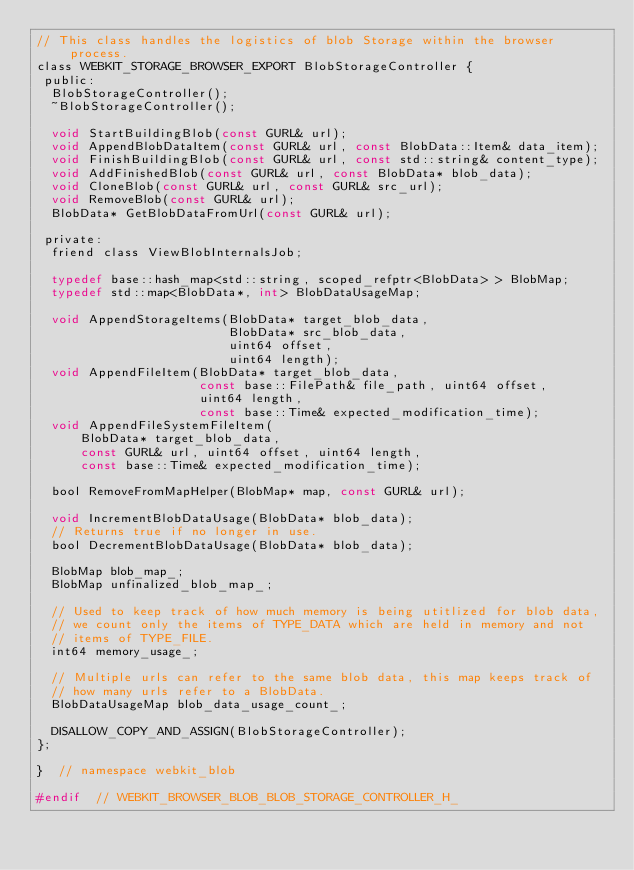Convert code to text. <code><loc_0><loc_0><loc_500><loc_500><_C_>// This class handles the logistics of blob Storage within the browser process.
class WEBKIT_STORAGE_BROWSER_EXPORT BlobStorageController {
 public:
  BlobStorageController();
  ~BlobStorageController();

  void StartBuildingBlob(const GURL& url);
  void AppendBlobDataItem(const GURL& url, const BlobData::Item& data_item);
  void FinishBuildingBlob(const GURL& url, const std::string& content_type);
  void AddFinishedBlob(const GURL& url, const BlobData* blob_data);
  void CloneBlob(const GURL& url, const GURL& src_url);
  void RemoveBlob(const GURL& url);
  BlobData* GetBlobDataFromUrl(const GURL& url);

 private:
  friend class ViewBlobInternalsJob;

  typedef base::hash_map<std::string, scoped_refptr<BlobData> > BlobMap;
  typedef std::map<BlobData*, int> BlobDataUsageMap;

  void AppendStorageItems(BlobData* target_blob_data,
                          BlobData* src_blob_data,
                          uint64 offset,
                          uint64 length);
  void AppendFileItem(BlobData* target_blob_data,
                      const base::FilePath& file_path, uint64 offset,
                      uint64 length,
                      const base::Time& expected_modification_time);
  void AppendFileSystemFileItem(
      BlobData* target_blob_data,
      const GURL& url, uint64 offset, uint64 length,
      const base::Time& expected_modification_time);

  bool RemoveFromMapHelper(BlobMap* map, const GURL& url);

  void IncrementBlobDataUsage(BlobData* blob_data);
  // Returns true if no longer in use.
  bool DecrementBlobDataUsage(BlobData* blob_data);

  BlobMap blob_map_;
  BlobMap unfinalized_blob_map_;

  // Used to keep track of how much memory is being utitlized for blob data,
  // we count only the items of TYPE_DATA which are held in memory and not
  // items of TYPE_FILE.
  int64 memory_usage_;

  // Multiple urls can refer to the same blob data, this map keeps track of
  // how many urls refer to a BlobData.
  BlobDataUsageMap blob_data_usage_count_;

  DISALLOW_COPY_AND_ASSIGN(BlobStorageController);
};

}  // namespace webkit_blob

#endif  // WEBKIT_BROWSER_BLOB_BLOB_STORAGE_CONTROLLER_H_
</code> 